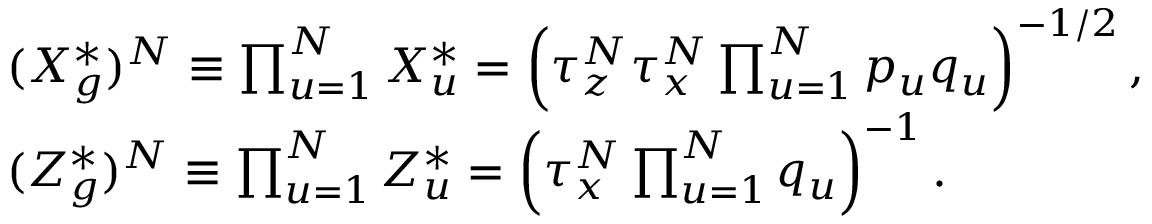Convert formula to latex. <formula><loc_0><loc_0><loc_500><loc_500>\begin{array} { r l } & { ( X _ { g } ^ { * } ) ^ { N } \equiv \prod _ { u = 1 } ^ { N } X _ { u } ^ { * } = \left ( \tau _ { z } ^ { N } \tau _ { x } ^ { N } \prod _ { u = 1 } ^ { N } p _ { u } q _ { u } \right ) ^ { - 1 / 2 } , } \\ & { ( Z _ { g } ^ { * } ) ^ { N } \equiv \prod _ { u = 1 } ^ { N } Z _ { u } ^ { * } = \left ( \tau _ { x } ^ { N } \prod _ { u = 1 } ^ { N } q _ { u } \right ) ^ { - 1 } . } \end{array}</formula> 